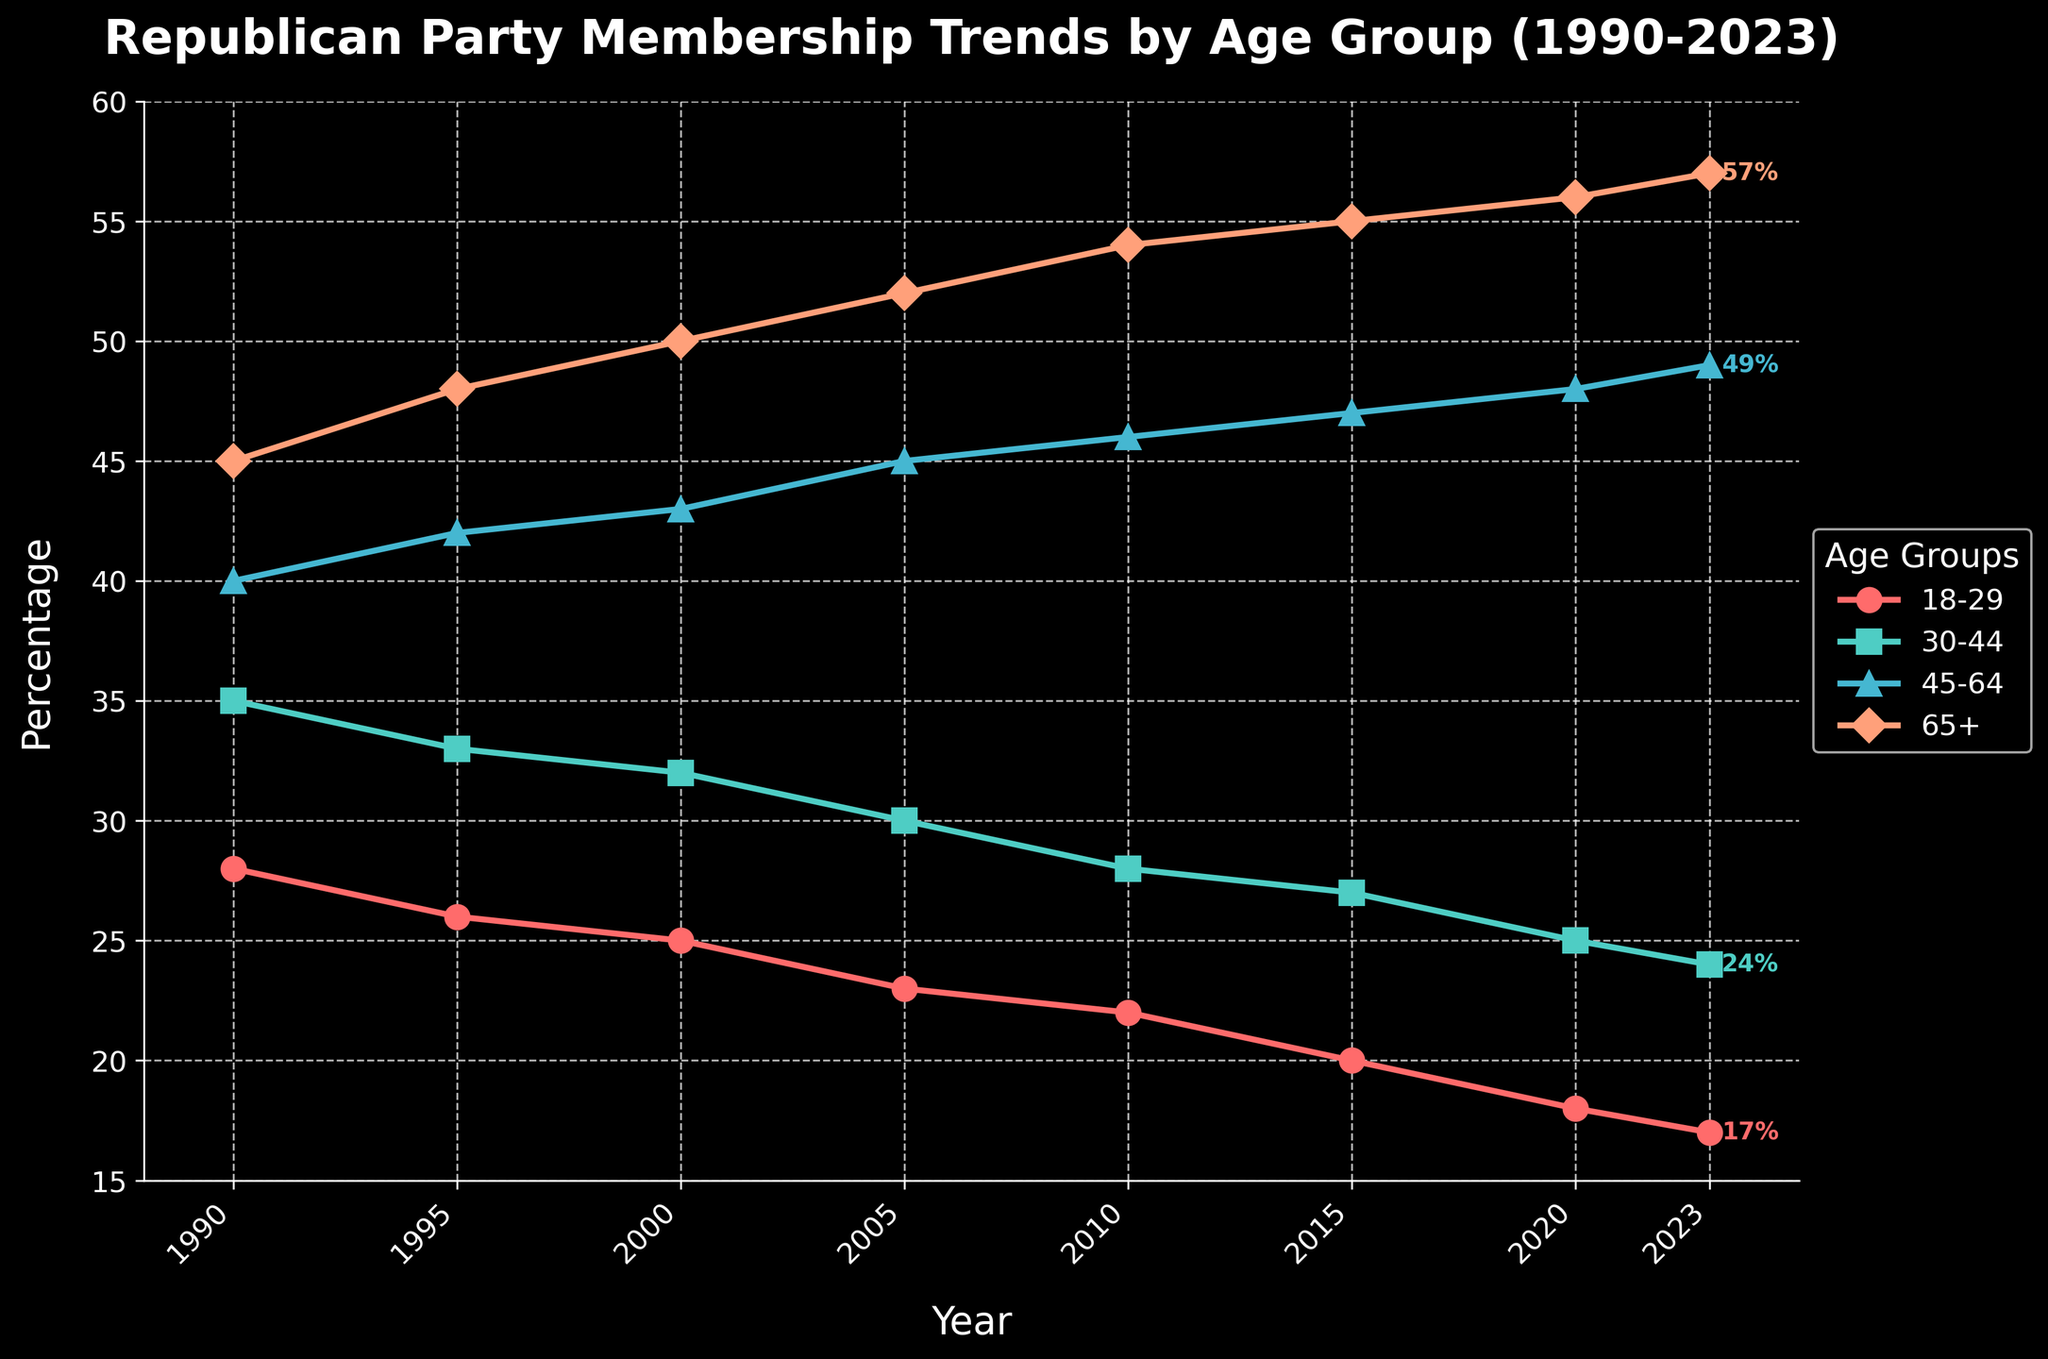What is the percentage of Republican Party membership in the 18-29 age group in 2023? The figure shows the trend lines for different age groups. Locate the line for the 18-29 age group and check its endpoint in 2023
Answer: 17% Which age group had the highest party membership percentage in 2020? Look at the endpoints of the lines in the year 2020 and find the one that reaches the highest point
Answer: 65+ What is the difference in Republican Party membership between the 30-44 and 18-29 age groups in 2000? Locate the points for the two age groups in 2000 and subtract the percentage of the 18-29 group from the 30-44 group
Answer: 7% By how many percentage points did Republican Party membership among the 45-64 age group increase from 1990 to 2023? Find the membership percentage for the 45-64 age group in 1990 and in 2023, then subtract the earlier percentage from the latter
Answer: 9% Which age group shows a consistent increase in Republican Party membership over the years? Examine the trend lines and identify the one that continually rises without dipping
Answer: 65+ Compare the Republican Party membership trends between the 30-44 and 45-64 age groups. Which group saw a faster increase from 2000 to 2023? Check the lines for the 30-44 and 45-64 age groups. Calculate the increase for each (2023 percentage - 2000 percentage) and compare
Answer: 45-64 What is the average percentage of Republican Party membership for the 65+ age group over the entire time period? Sum the membership percentages of the 65+ age group for all years listed and divide by the number of data points (8)
Answer: 52.125% Which age group had the largest decline in Republican Party membership from 1990 to 2023? Find the difference in percentages from 1990 to 2023 for each age group and identify the largest negative value
Answer: 18-29 